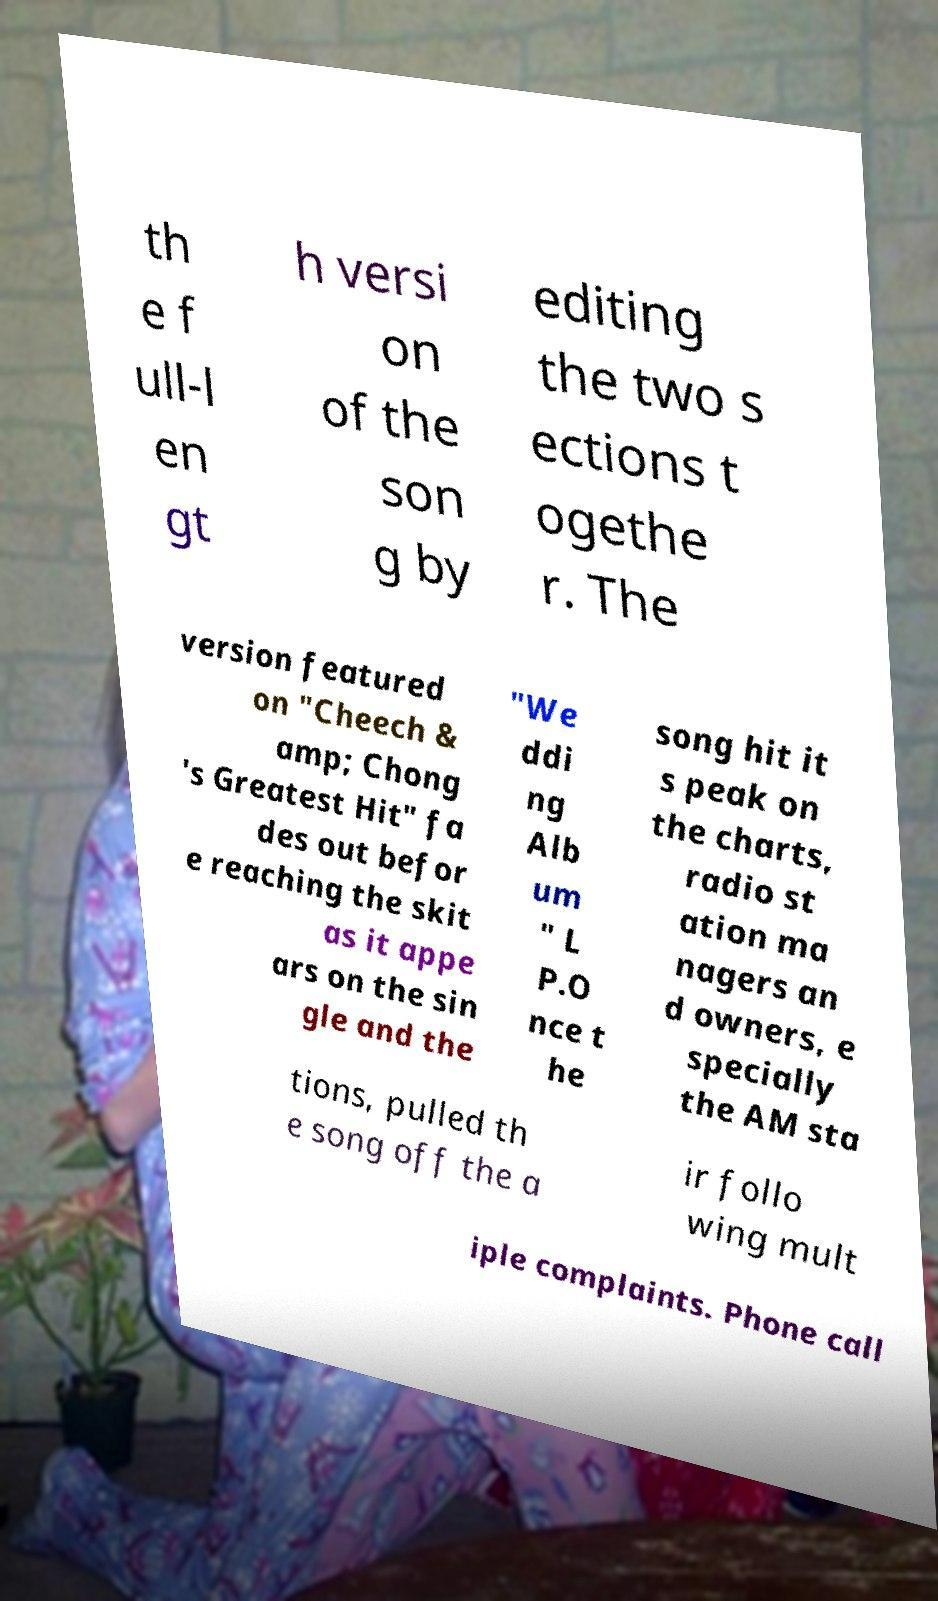I need the written content from this picture converted into text. Can you do that? th e f ull-l en gt h versi on of the son g by editing the two s ections t ogethe r. The version featured on "Cheech & amp; Chong 's Greatest Hit" fa des out befor e reaching the skit as it appe ars on the sin gle and the "We ddi ng Alb um " L P.O nce t he song hit it s peak on the charts, radio st ation ma nagers an d owners, e specially the AM sta tions, pulled th e song off the a ir follo wing mult iple complaints. Phone call 